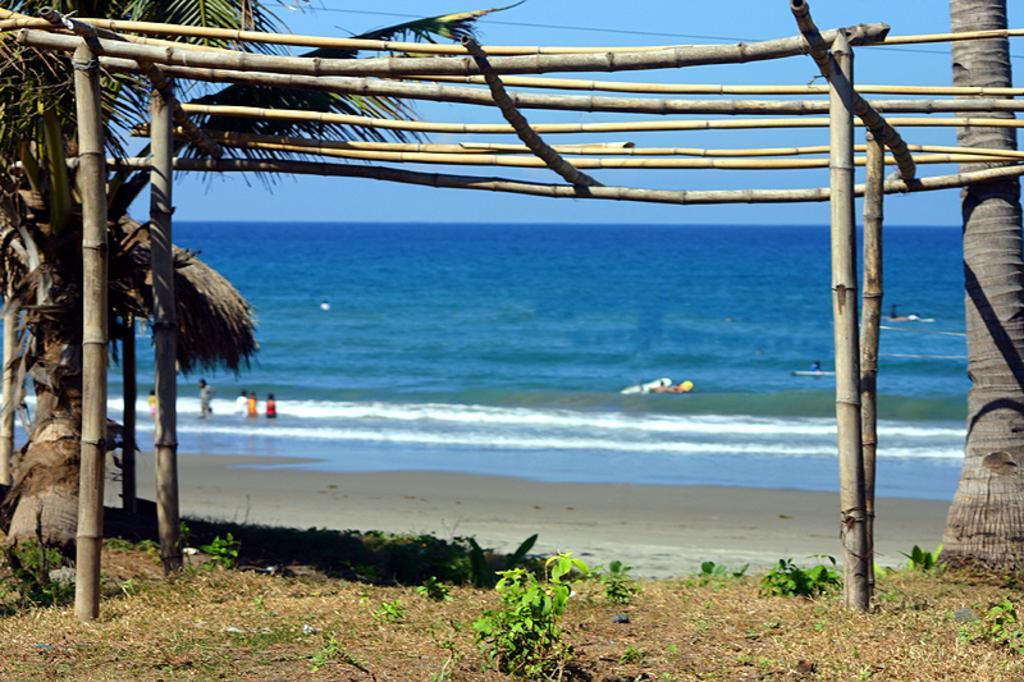Could you give a brief overview of what you see in this image? This is the picture of a sea. In the foreground there are bamboo sticks and there are trees. At the back there are group of people standing in the water. At the top there is sky. At the bottom there is water and sand. In the foreground there are plants. 